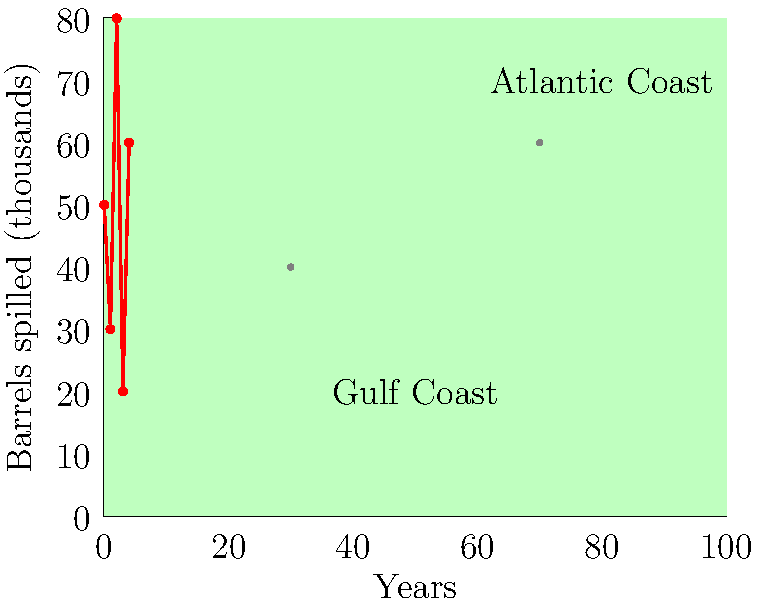Based on the map and chart provided, which coastal region appears to have experienced more frequent oil spills, and how does this relate to the trend shown in the chart for barrels of oil spilled over the years? To answer this question, we need to analyze both the map and the chart:

1. Map analysis:
   - The map shows two main coastal regions: Gulf Coast and Atlantic Coast.
   - There are two oil spill markers on the map.
   - One marker is located near the Gulf Coast.
   - The other marker is located near the Atlantic Coast.
   - The Gulf Coast marker appears larger, suggesting a more significant spill.

2. Chart analysis:
   - The chart shows the number of barrels spilled (in thousands) over 5 years.
   - The trend is irregular, with peaks and valleys.
   - Years 0, 2, and 4 show higher spill volumes.
   - Years 1 and 3 show lower spill volumes.

3. Connecting map and chart:
   - The larger spill marker on the Gulf Coast suggests more frequent or severe spills in this region.
   - This aligns with the chart's irregular pattern, which could indicate periodic large spills.
   - The Gulf Coast's prominence in the petroleum industry makes it more susceptible to spills.

4. Conclusion:
   - The Gulf Coast appears to have experienced more frequent oil spills.
   - The chart's irregular trend supports this, showing periodic spikes in spill volume that could correspond to major Gulf Coast incidents.
Answer: Gulf Coast; irregular spill pattern supports frequent Gulf incidents 